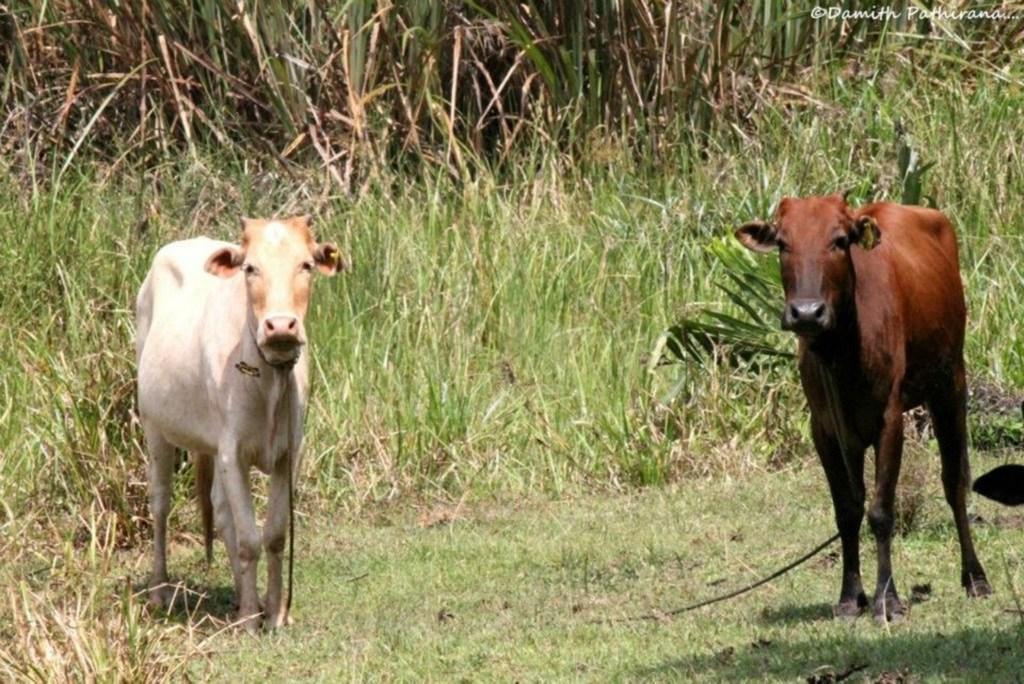Can you describe this image briefly? In this picture we can see two cows standing on a grass and in the background we can see trees and this are in white and brown color. 